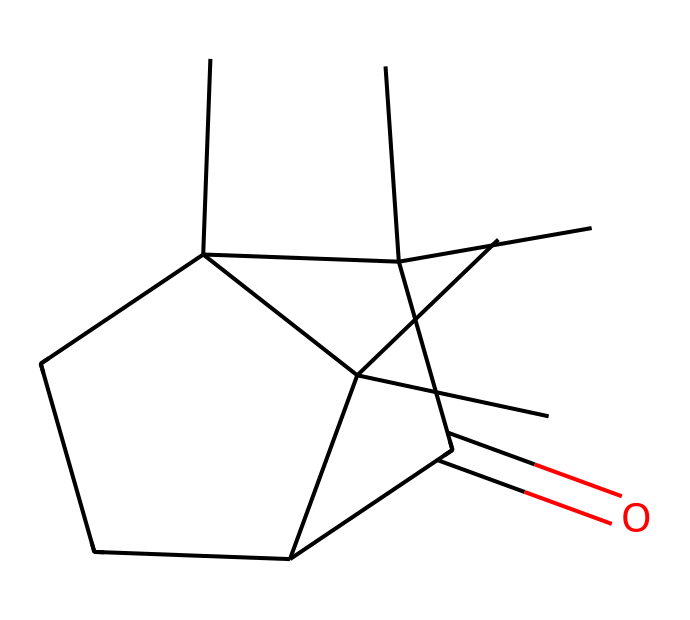What is the name of the chemical based on its SMILES representation? By interpreting the SMILES representation, I see that the molecular structure represents camphor, which is a commonly recognized compound.
Answer: camphor How many chiral centers are present in camphor? A chiral center is identified by the presence of a carbon atom bonded to four different substituents. In the structure of camphor, there is one carbon atom meeting this criterion.
Answer: one What functional group is present in camphor? The SMILES indicates a ketone functional group due to the carbonyl (C=O) part of the structure, which is characteristic of camphor.
Answer: ketone Which type of stereochemistry does camphor exhibit? Camphor exhibits a specific type of stereochemistry called chirality because it has a chiral center that leads to the existence of enantiomers.
Answer: chirality What is the molecular formula of camphor? By analyzing the structure, I can count the number of each type of atom, leading to the molecular formula C10H16O.
Answer: C10H16O Why is camphor used in vintage record preservation? Camphor has properties that help preserve and protect materials from damage and degradation, making it valuable in the preservation of vintage records.
Answer: preservation properties 